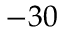Convert formula to latex. <formula><loc_0><loc_0><loc_500><loc_500>- 3 0</formula> 